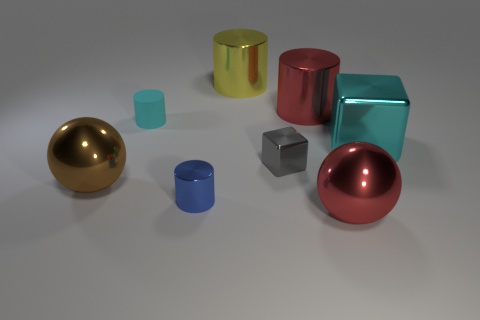There is a yellow thing that is right of the cyan rubber cylinder; is there a thing that is in front of it?
Keep it short and to the point. Yes. How many blue cylinders are there?
Keep it short and to the point. 1. What is the color of the thing that is both in front of the large cyan block and behind the brown metal ball?
Offer a terse response. Gray. There is another thing that is the same shape as the cyan metallic object; what size is it?
Ensure brevity in your answer.  Small. How many gray cubes are the same size as the red metal sphere?
Your answer should be compact. 0. What is the red cylinder made of?
Ensure brevity in your answer.  Metal. Are there any tiny blue shiny cylinders behind the rubber thing?
Your response must be concise. No. There is a blue object that is the same material as the tiny gray block; what size is it?
Your answer should be very brief. Small. What number of tiny rubber cylinders are the same color as the tiny metal cube?
Make the answer very short. 0. Are there fewer tiny blue metallic objects behind the yellow thing than large yellow objects that are to the left of the small blue shiny object?
Your response must be concise. No. 